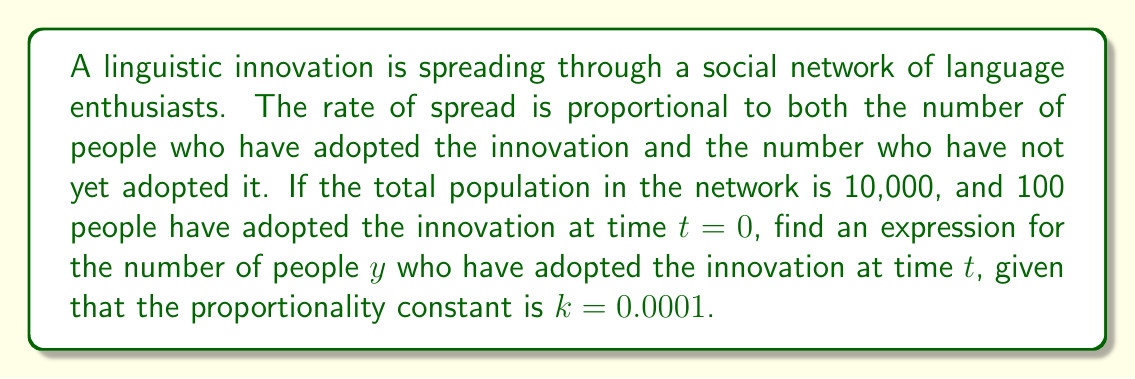Give your solution to this math problem. Let's approach this step-by-step:

1) Let $y(t)$ be the number of people who have adopted the innovation at time $t$.

2) The rate of change of $y$ with respect to $t$ is proportional to $y$ (those who have adopted) and $(10000 - y)$ (those who haven't adopted yet).

3) This gives us the differential equation:

   $$\frac{dy}{dt} = ky(10000 - y)$$

   where $k = 0.0001$ is the proportionality constant.

4) This is a separable differential equation. We can rewrite it as:

   $$\frac{dy}{y(10000 - y)} = 0.0001 dt$$

5) Integrating both sides:

   $$\int \frac{dy}{y(10000 - y)} = \int 0.0001 dt$$

6) The left side can be integrated using partial fractions:

   $$\frac{1}{10000} \ln\left|\frac{y}{10000-y}\right| = 0.0001t + C$$

7) Using the initial condition $y(0) = 100$, we can find $C$:

   $$\frac{1}{10000} \ln\left|\frac{100}{9900}\right| = C$$

8) Substituting this back and simplifying:

   $$\ln\left|\frac{y}{10000-y}\right| = t + \ln\left|\frac{100}{9900}\right|$$

9) Solving for $y$:

   $$\frac{y}{10000-y} = \frac{100}{9900}e^t$$

   $$y = \frac{1000000e^t}{99e^t + 1}$$

This is the logistic function, which is commonly used to model the spread of innovations.
Answer: $$y(t) = \frac{1000000e^t}{99e^t + 1}$$ 